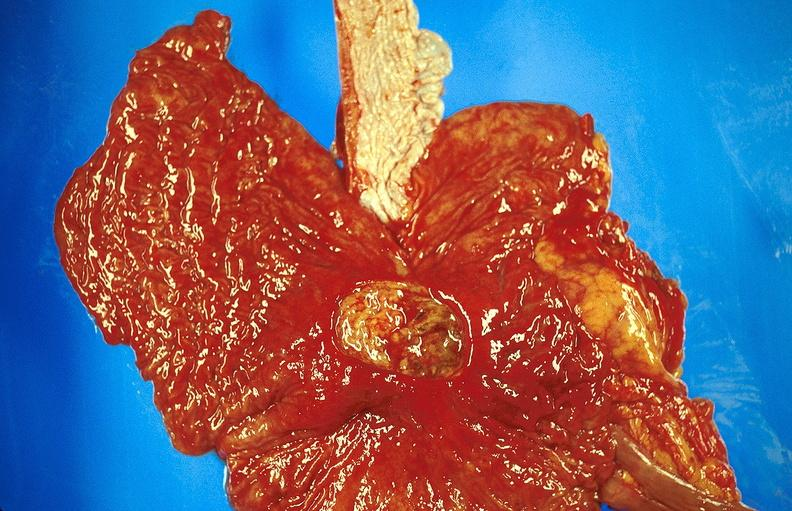s hypertension present?
Answer the question using a single word or phrase. No 